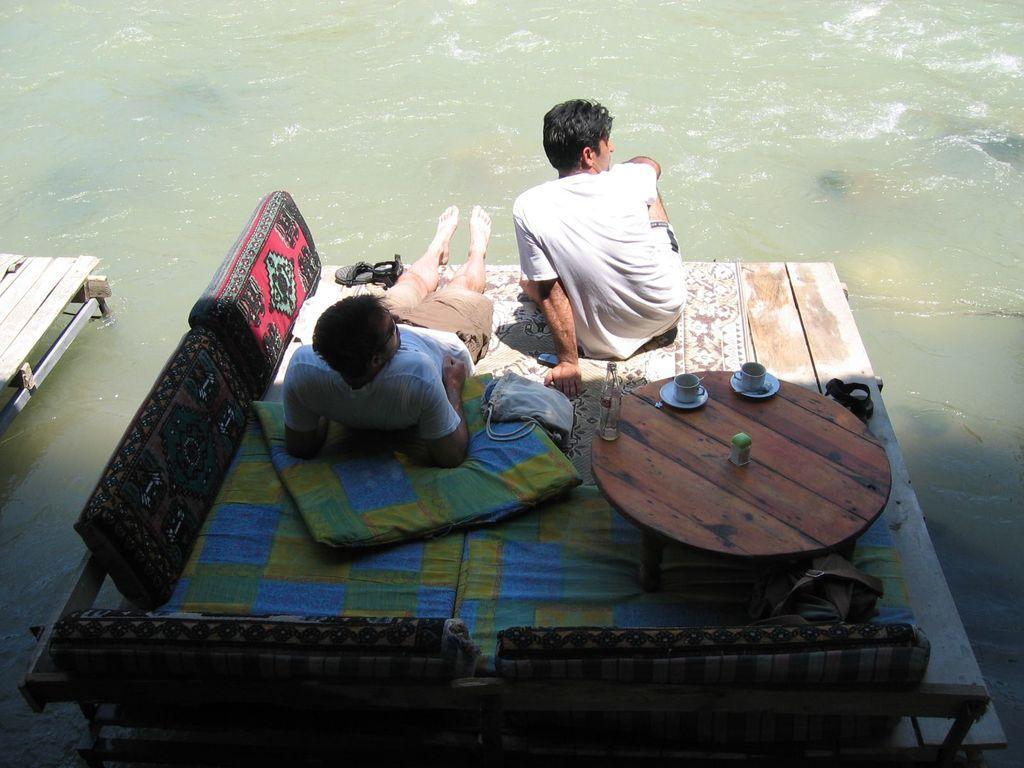Describe this image in one or two sentences. Here a man is laying on a wooden plank and a man is sitting on a wooden plank by observing the water. Pillows, tea cups on the table. 